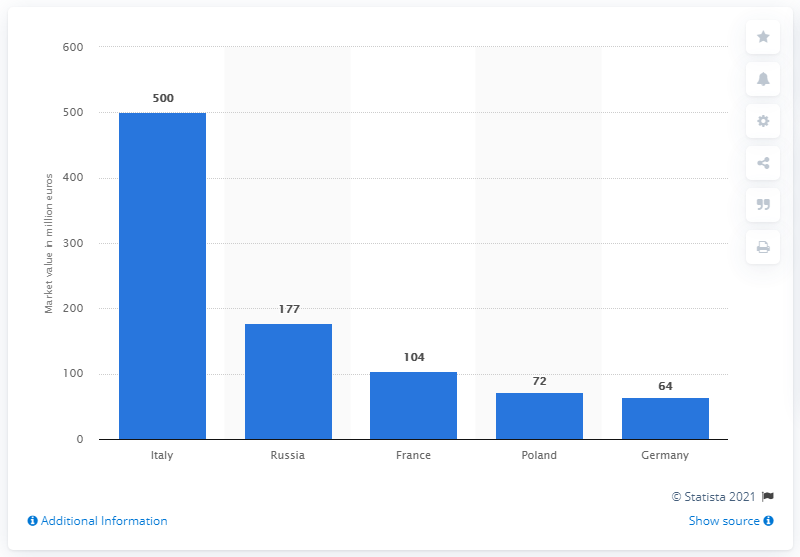Outline some significant characteristics in this image. Russia has the largest market for probiotic supplements. The value of Italy's probiotic supplement market is 500 million. 